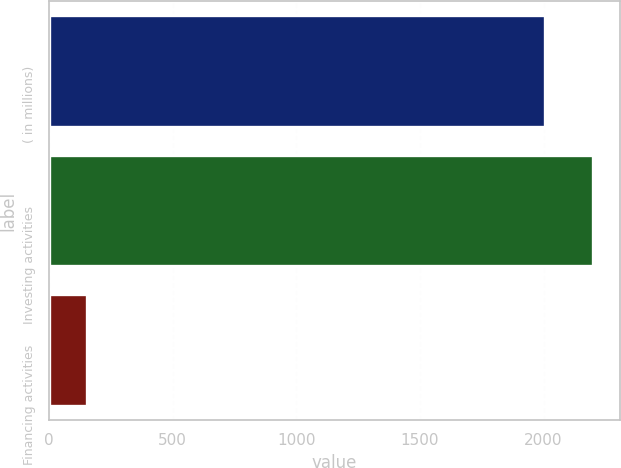Convert chart. <chart><loc_0><loc_0><loc_500><loc_500><bar_chart><fcel>( in millions)<fcel>Investing activities<fcel>Financing activities<nl><fcel>2006<fcel>2198.2<fcel>152<nl></chart> 